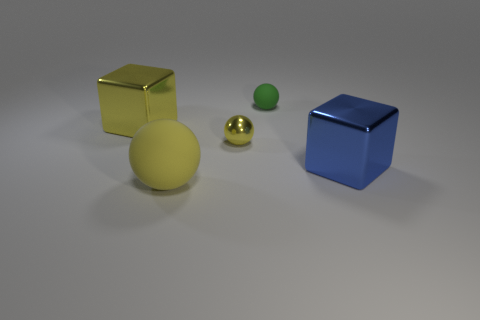What number of other objects are the same material as the tiny yellow object?
Your answer should be compact. 2. There is a green sphere that is the same size as the yellow shiny ball; what is its material?
Your answer should be compact. Rubber. Is the number of big yellow things on the right side of the big blue metallic object less than the number of tiny yellow shiny spheres?
Your response must be concise. Yes. There is a matte object that is behind the shiny block on the right side of the metal cube left of the large blue metal thing; what is its shape?
Give a very brief answer. Sphere. There is a rubber sphere that is to the left of the small yellow metallic object; how big is it?
Keep it short and to the point. Large. There is a yellow matte thing that is the same size as the blue metal block; what shape is it?
Offer a terse response. Sphere. How many things are either small green matte balls or yellow balls behind the blue metallic block?
Give a very brief answer. 2. There is a big cube that is in front of the yellow metallic thing that is left of the large sphere; what number of green objects are to the left of it?
Keep it short and to the point. 1. The block that is the same material as the blue thing is what color?
Provide a short and direct response. Yellow. There is a object to the right of the green object; is its size the same as the big yellow rubber sphere?
Ensure brevity in your answer.  Yes. 